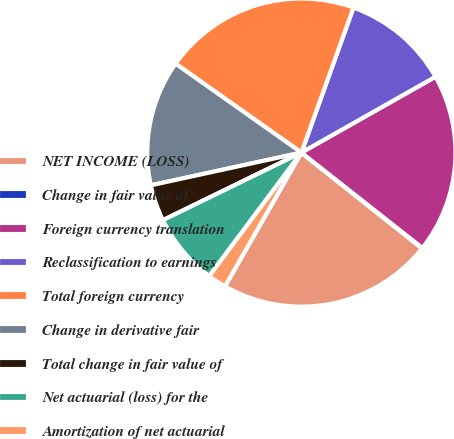Convert chart to OTSL. <chart><loc_0><loc_0><loc_500><loc_500><pie_chart><fcel>NET INCOME (LOSS)<fcel>Change in fair value of<fcel>Foreign currency translation<fcel>Reclassification to earnings<fcel>Total foreign currency<fcel>Change in derivative fair<fcel>Total change in fair value of<fcel>Net actuarial (loss) for the<fcel>Amortization of net actuarial<nl><fcel>22.58%<fcel>0.06%<fcel>18.82%<fcel>11.32%<fcel>20.7%<fcel>13.2%<fcel>3.82%<fcel>7.57%<fcel>1.94%<nl></chart> 